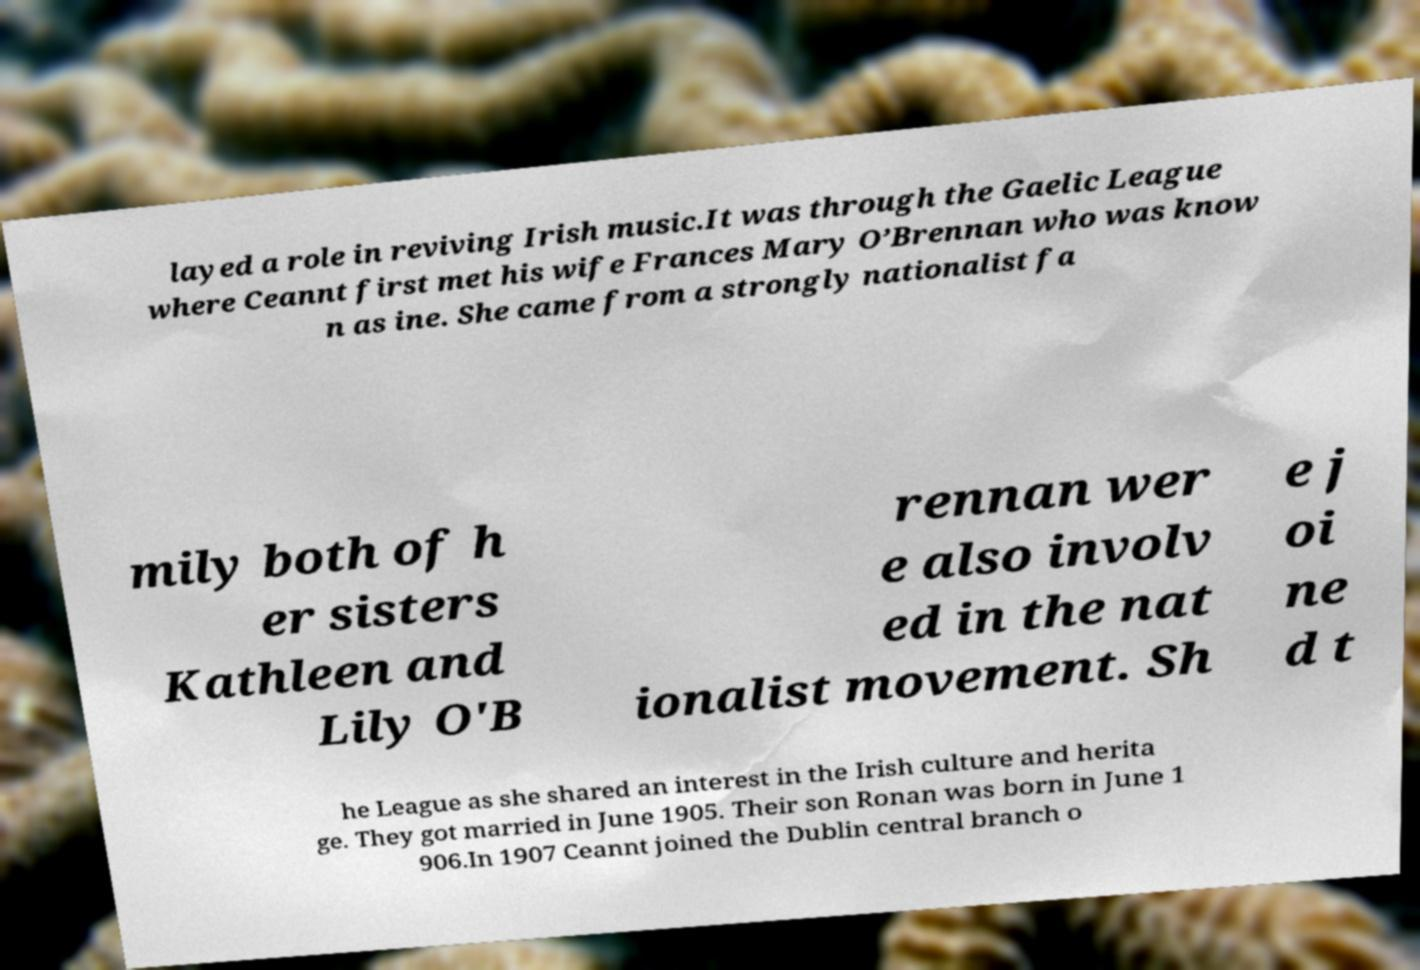Can you accurately transcribe the text from the provided image for me? layed a role in reviving Irish music.It was through the Gaelic League where Ceannt first met his wife Frances Mary O’Brennan who was know n as ine. She came from a strongly nationalist fa mily both of h er sisters Kathleen and Lily O'B rennan wer e also involv ed in the nat ionalist movement. Sh e j oi ne d t he League as she shared an interest in the Irish culture and herita ge. They got married in June 1905. Their son Ronan was born in June 1 906.In 1907 Ceannt joined the Dublin central branch o 